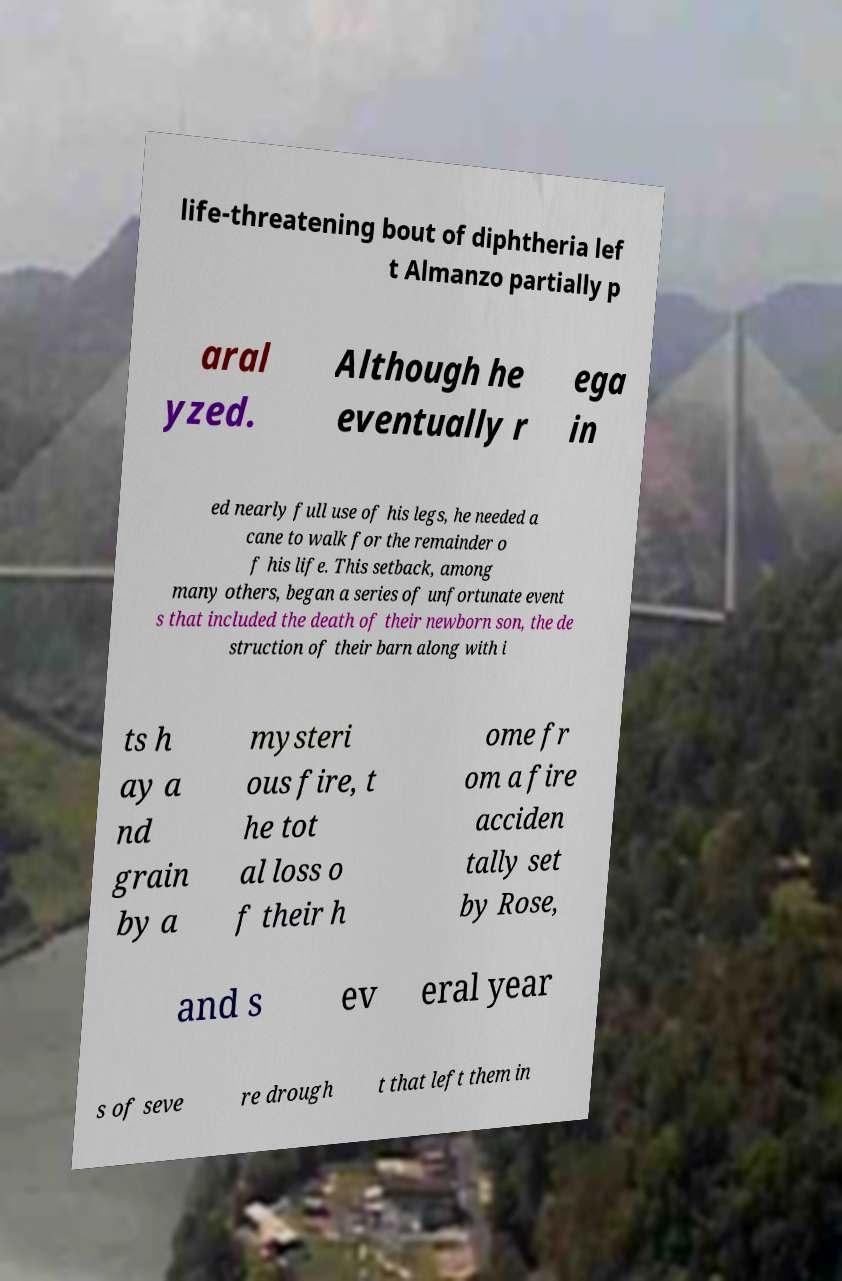There's text embedded in this image that I need extracted. Can you transcribe it verbatim? life-threatening bout of diphtheria lef t Almanzo partially p aral yzed. Although he eventually r ega in ed nearly full use of his legs, he needed a cane to walk for the remainder o f his life. This setback, among many others, began a series of unfortunate event s that included the death of their newborn son, the de struction of their barn along with i ts h ay a nd grain by a mysteri ous fire, t he tot al loss o f their h ome fr om a fire acciden tally set by Rose, and s ev eral year s of seve re drough t that left them in 